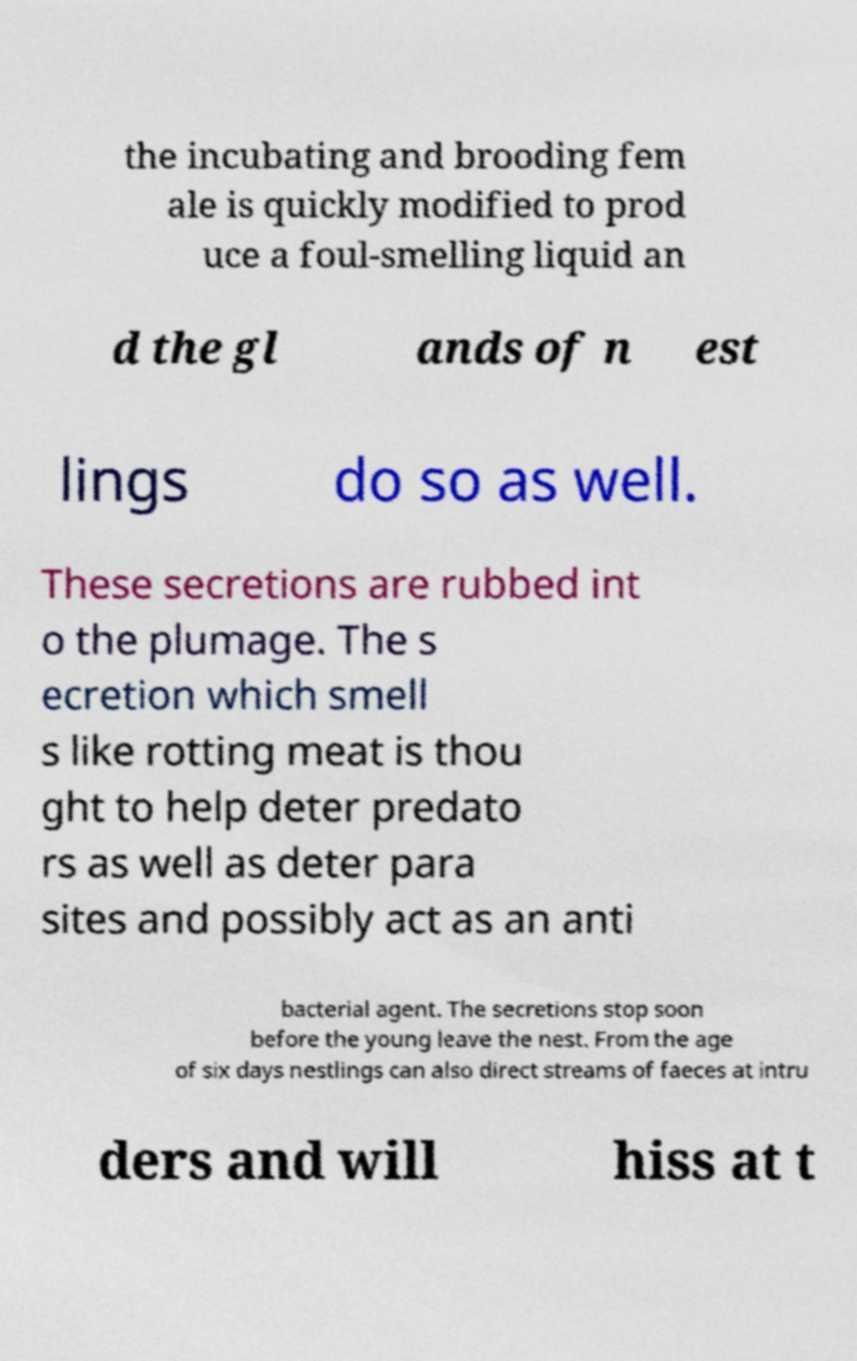Can you read and provide the text displayed in the image?This photo seems to have some interesting text. Can you extract and type it out for me? the incubating and brooding fem ale is quickly modified to prod uce a foul-smelling liquid an d the gl ands of n est lings do so as well. These secretions are rubbed int o the plumage. The s ecretion which smell s like rotting meat is thou ght to help deter predato rs as well as deter para sites and possibly act as an anti bacterial agent. The secretions stop soon before the young leave the nest. From the age of six days nestlings can also direct streams of faeces at intru ders and will hiss at t 